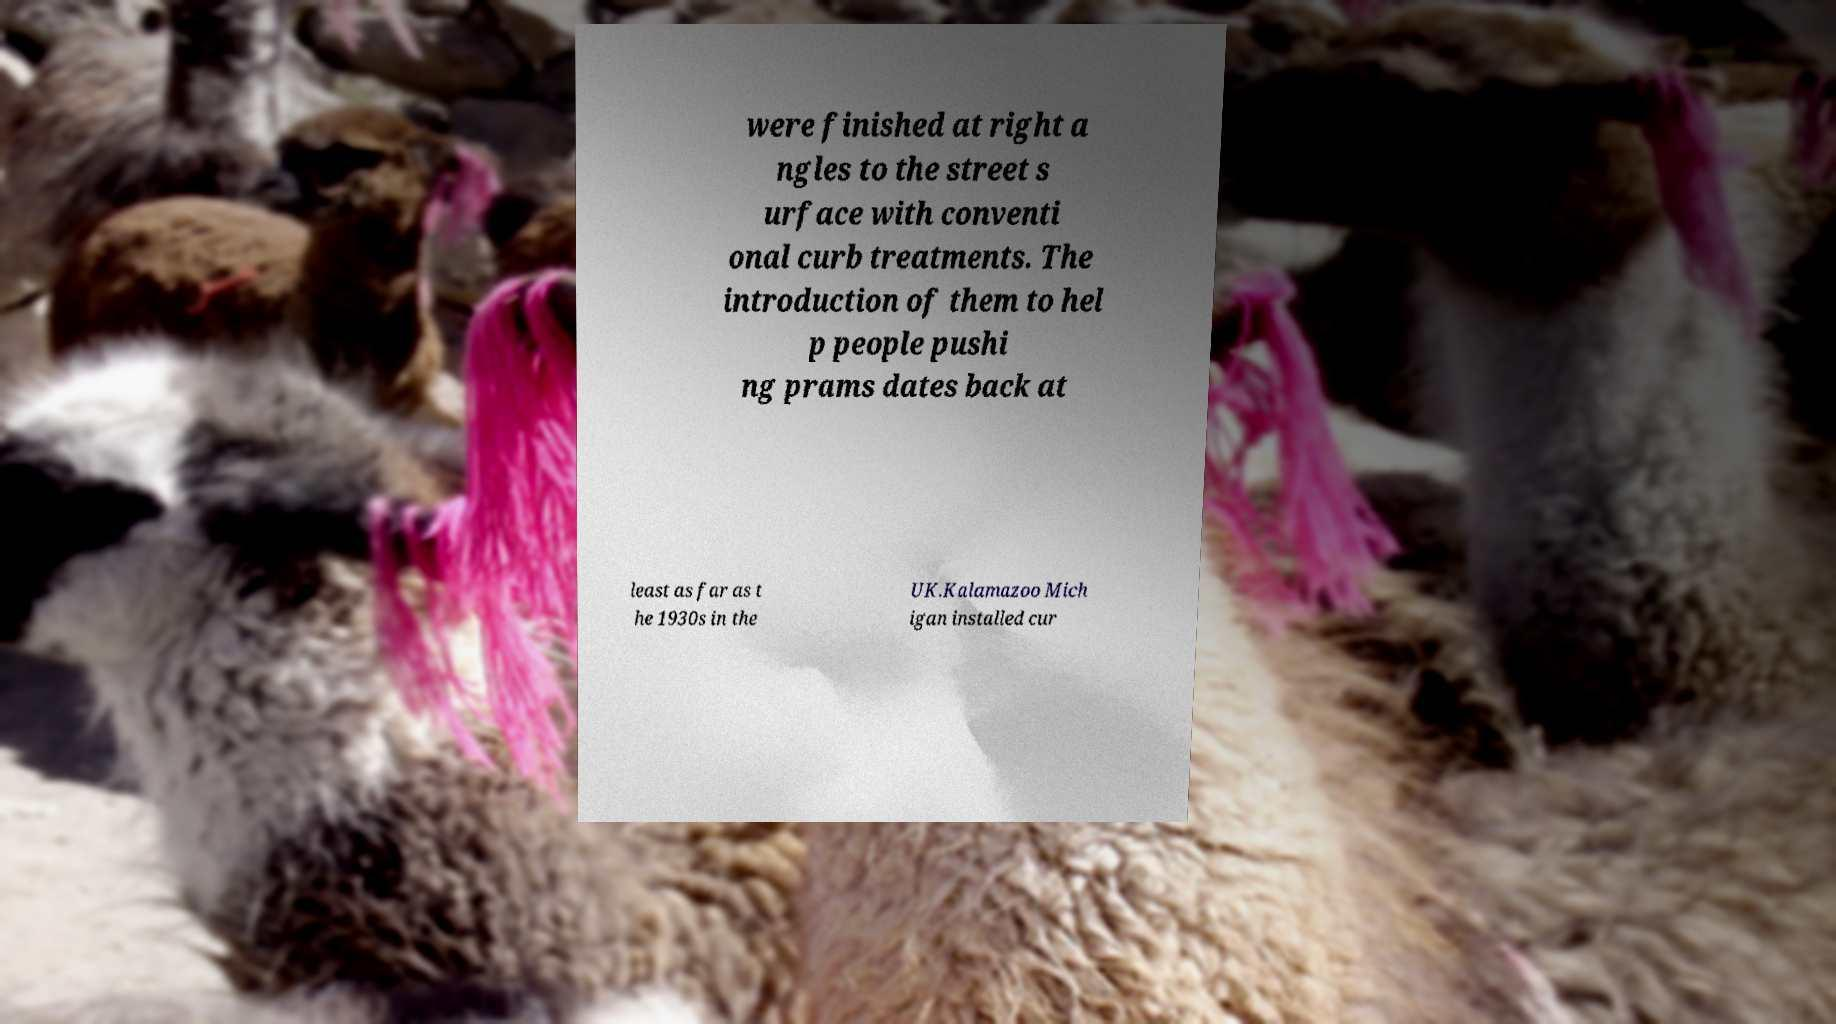Could you assist in decoding the text presented in this image and type it out clearly? were finished at right a ngles to the street s urface with conventi onal curb treatments. The introduction of them to hel p people pushi ng prams dates back at least as far as t he 1930s in the UK.Kalamazoo Mich igan installed cur 